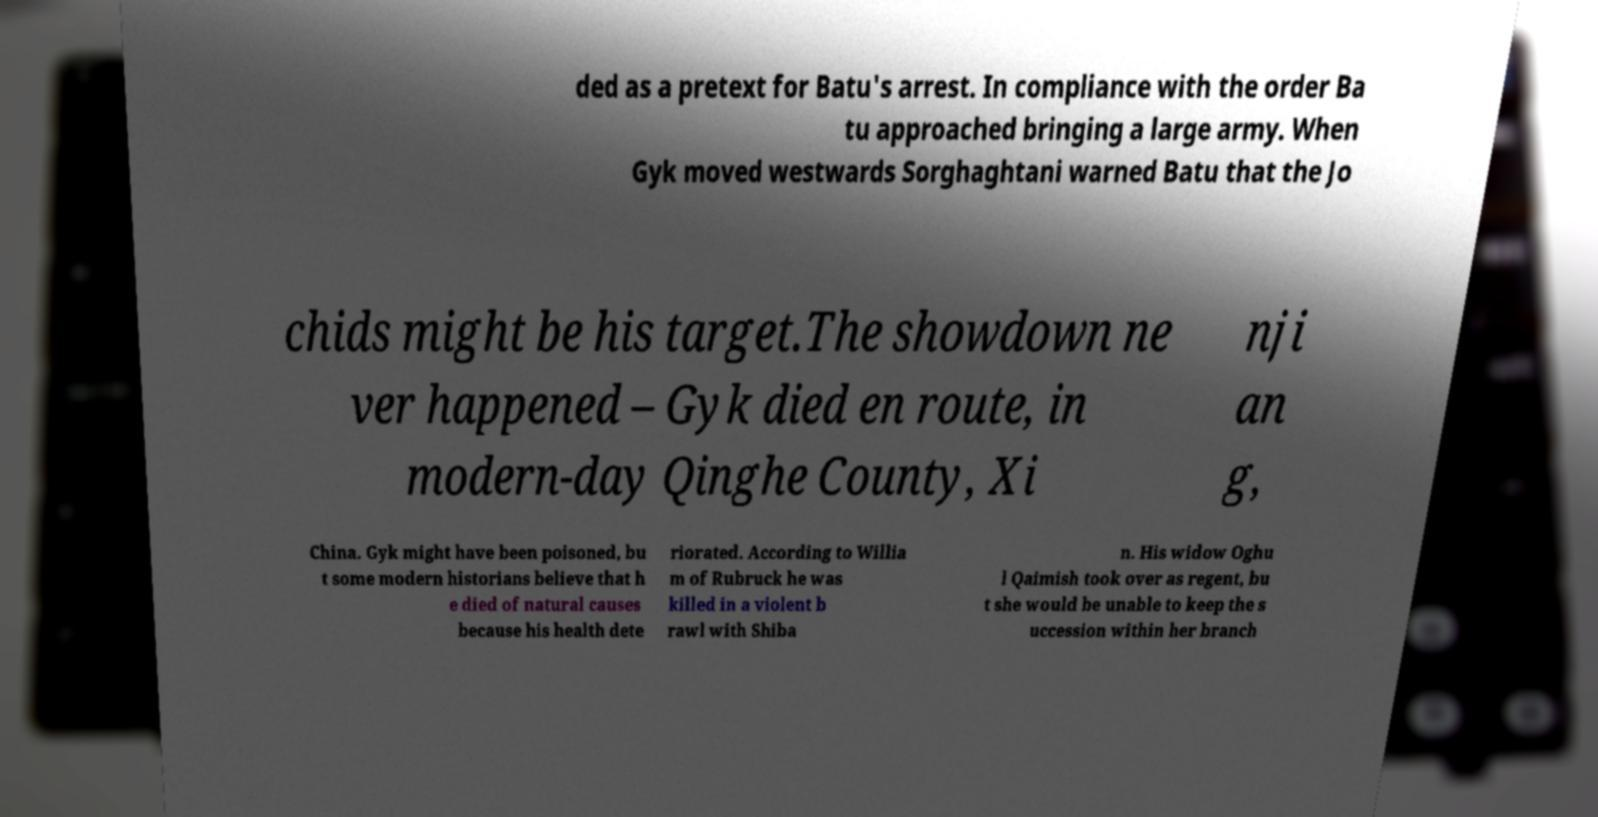For documentation purposes, I need the text within this image transcribed. Could you provide that? ded as a pretext for Batu's arrest. In compliance with the order Ba tu approached bringing a large army. When Gyk moved westwards Sorghaghtani warned Batu that the Jo chids might be his target.The showdown ne ver happened – Gyk died en route, in modern-day Qinghe County, Xi nji an g, China. Gyk might have been poisoned, bu t some modern historians believe that h e died of natural causes because his health dete riorated. According to Willia m of Rubruck he was killed in a violent b rawl with Shiba n. His widow Oghu l Qaimish took over as regent, bu t she would be unable to keep the s uccession within her branch 